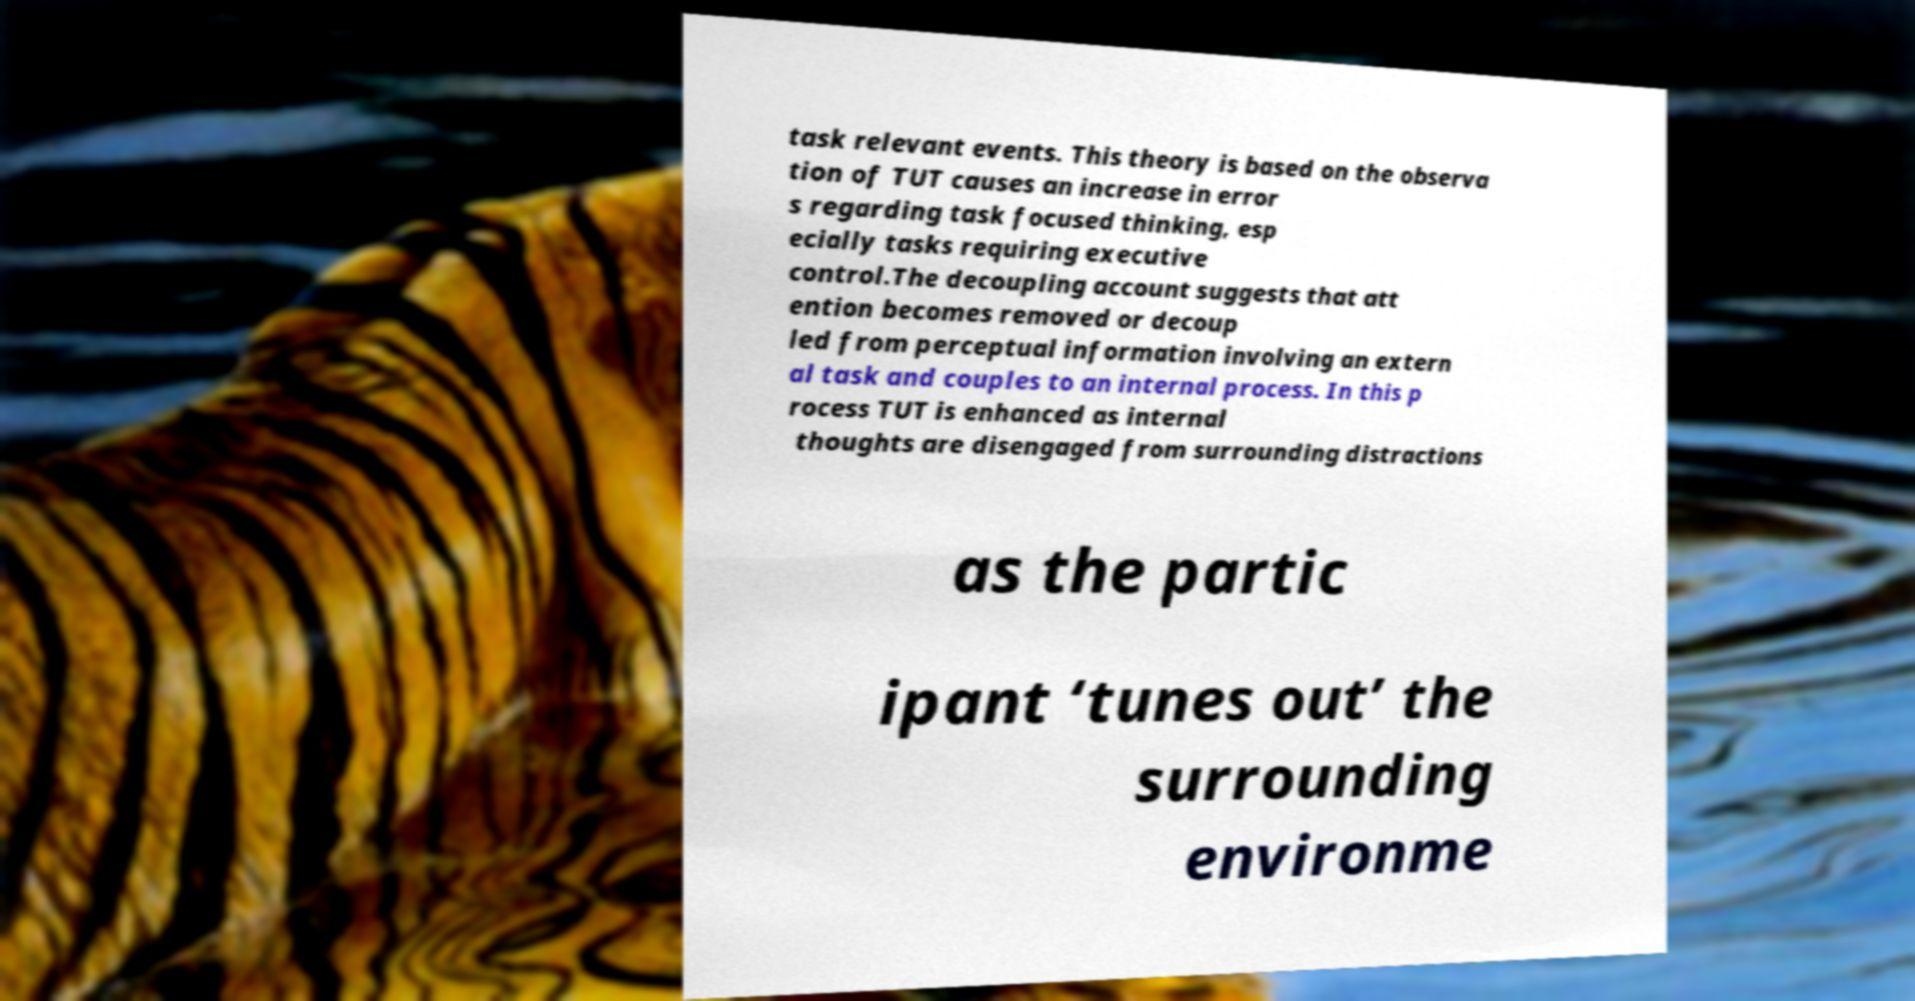Can you accurately transcribe the text from the provided image for me? task relevant events. This theory is based on the observa tion of TUT causes an increase in error s regarding task focused thinking, esp ecially tasks requiring executive control.The decoupling account suggests that att ention becomes removed or decoup led from perceptual information involving an extern al task and couples to an internal process. In this p rocess TUT is enhanced as internal thoughts are disengaged from surrounding distractions as the partic ipant ‘tunes out’ the surrounding environme 